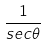<formula> <loc_0><loc_0><loc_500><loc_500>\frac { 1 } { s e c \theta }</formula> 